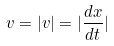<formula> <loc_0><loc_0><loc_500><loc_500>v = | v | = | \frac { d x } { d t } |</formula> 